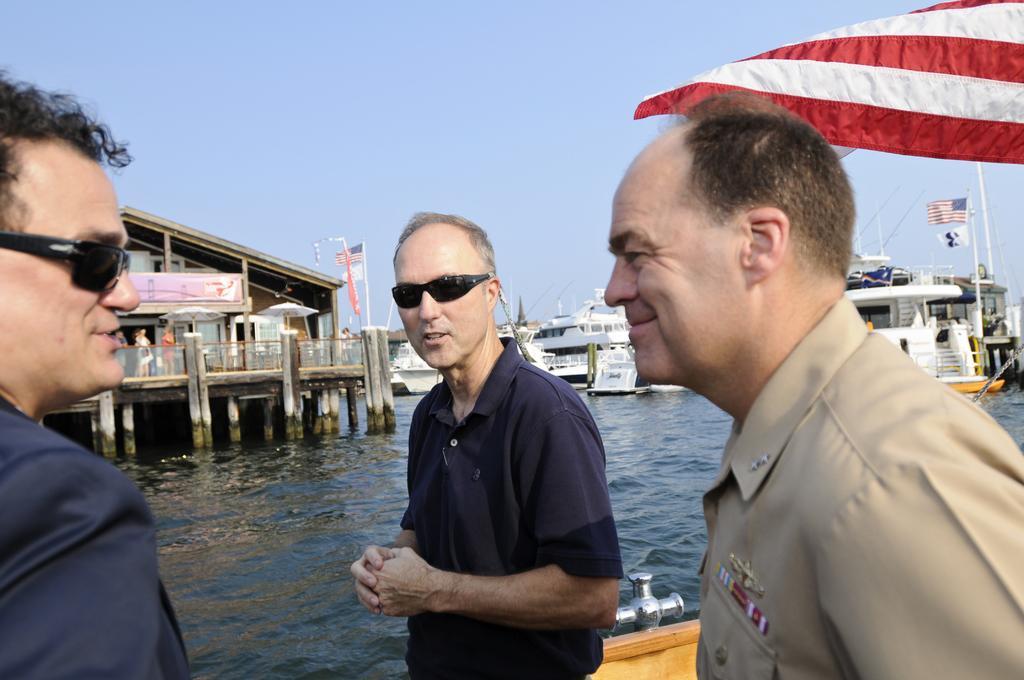Please provide a concise description of this image. In this image, we can see a few people standing. We can also see some ships and houses, sailing on the water. We can see some flags. We can also see the sky. 